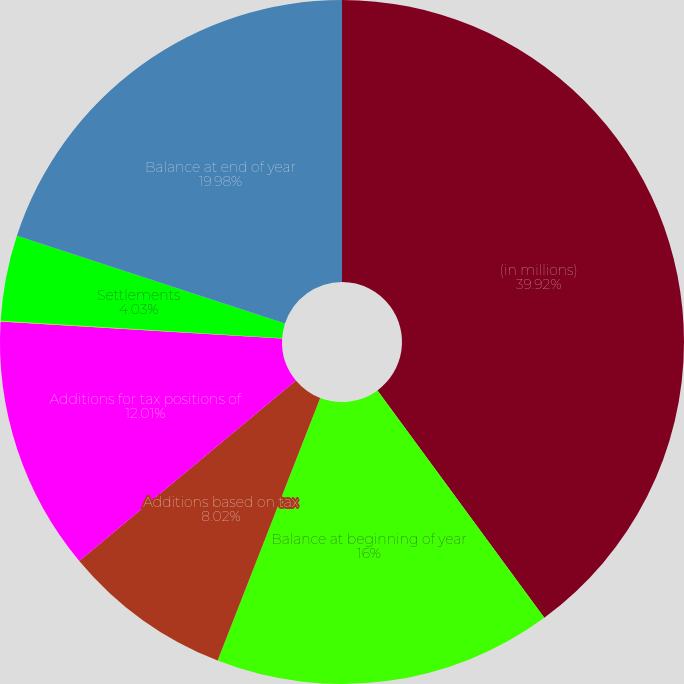Convert chart to OTSL. <chart><loc_0><loc_0><loc_500><loc_500><pie_chart><fcel>(in millions)<fcel>Balance at beginning of year<fcel>Additions based on tax<fcel>Additions for tax positions of<fcel>Reductions for tax positions<fcel>Settlements<fcel>Balance at end of year<nl><fcel>39.93%<fcel>16.0%<fcel>8.02%<fcel>12.01%<fcel>0.04%<fcel>4.03%<fcel>19.98%<nl></chart> 